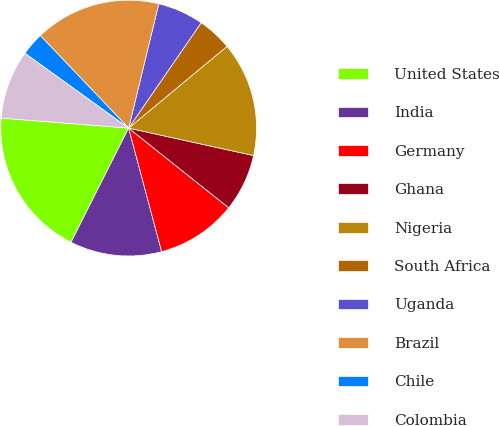Convert chart. <chart><loc_0><loc_0><loc_500><loc_500><pie_chart><fcel>United States<fcel>India<fcel>Germany<fcel>Ghana<fcel>Nigeria<fcel>South Africa<fcel>Uganda<fcel>Brazil<fcel>Chile<fcel>Colombia<nl><fcel>18.81%<fcel>11.59%<fcel>10.14%<fcel>7.26%<fcel>14.48%<fcel>4.37%<fcel>5.81%<fcel>15.92%<fcel>2.92%<fcel>8.7%<nl></chart> 